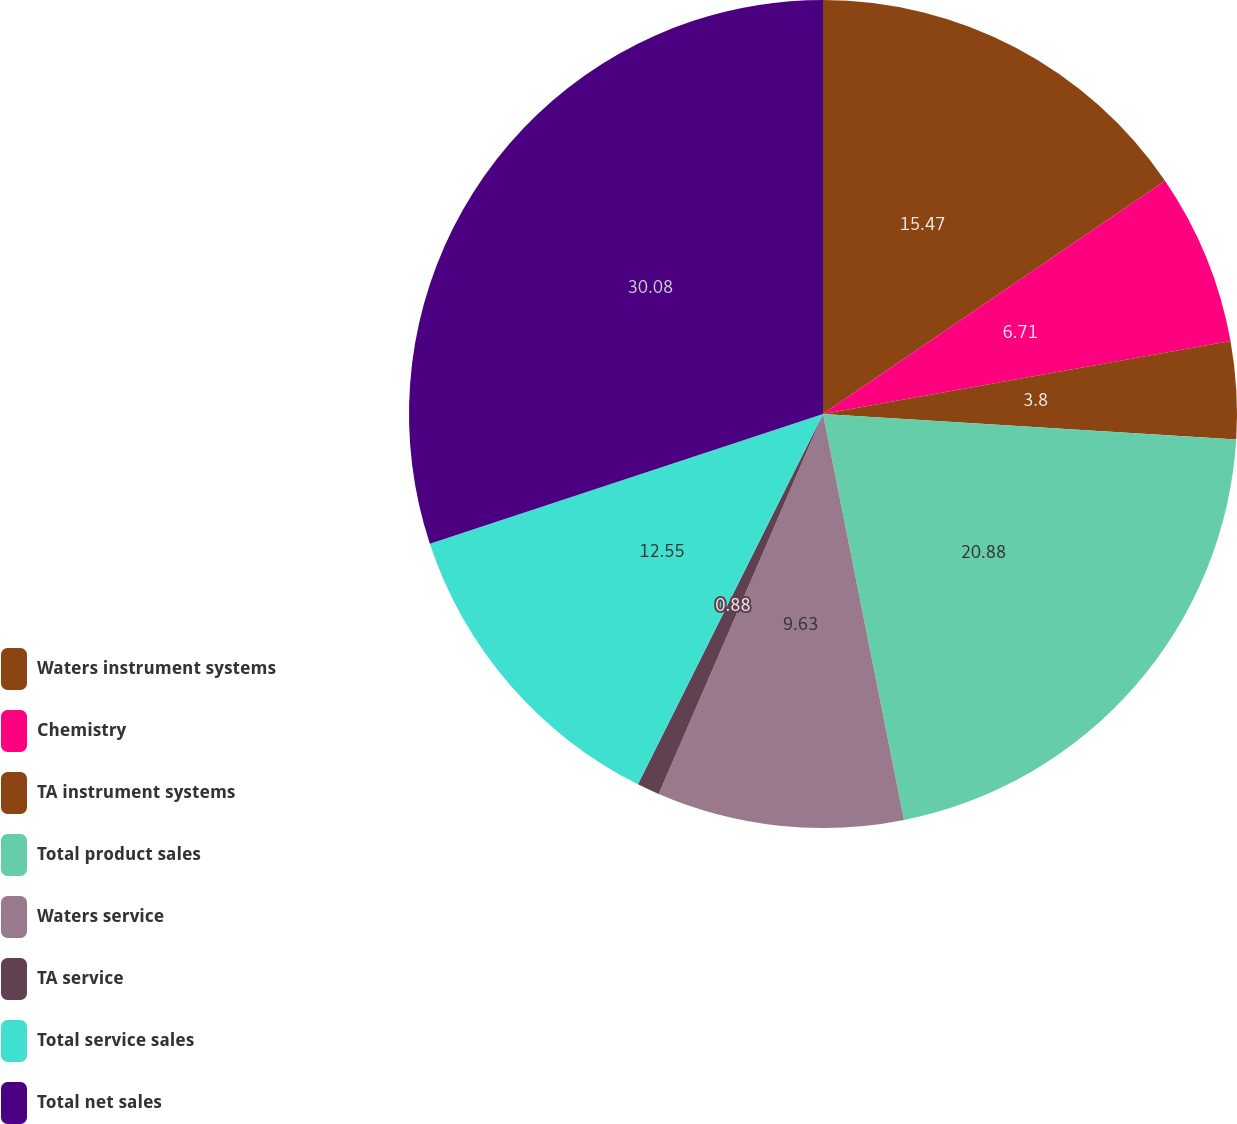<chart> <loc_0><loc_0><loc_500><loc_500><pie_chart><fcel>Waters instrument systems<fcel>Chemistry<fcel>TA instrument systems<fcel>Total product sales<fcel>Waters service<fcel>TA service<fcel>Total service sales<fcel>Total net sales<nl><fcel>15.47%<fcel>6.71%<fcel>3.8%<fcel>20.88%<fcel>9.63%<fcel>0.88%<fcel>12.55%<fcel>30.07%<nl></chart> 